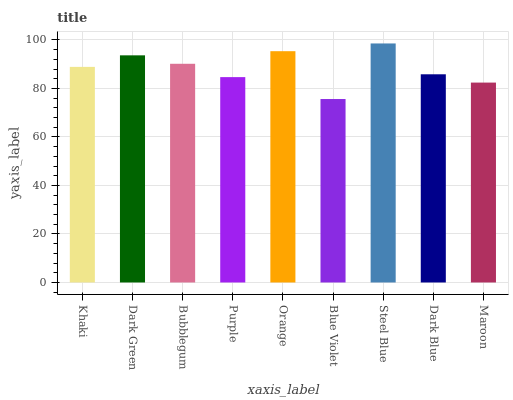Is Blue Violet the minimum?
Answer yes or no. Yes. Is Steel Blue the maximum?
Answer yes or no. Yes. Is Dark Green the minimum?
Answer yes or no. No. Is Dark Green the maximum?
Answer yes or no. No. Is Dark Green greater than Khaki?
Answer yes or no. Yes. Is Khaki less than Dark Green?
Answer yes or no. Yes. Is Khaki greater than Dark Green?
Answer yes or no. No. Is Dark Green less than Khaki?
Answer yes or no. No. Is Khaki the high median?
Answer yes or no. Yes. Is Khaki the low median?
Answer yes or no. Yes. Is Orange the high median?
Answer yes or no. No. Is Dark Blue the low median?
Answer yes or no. No. 